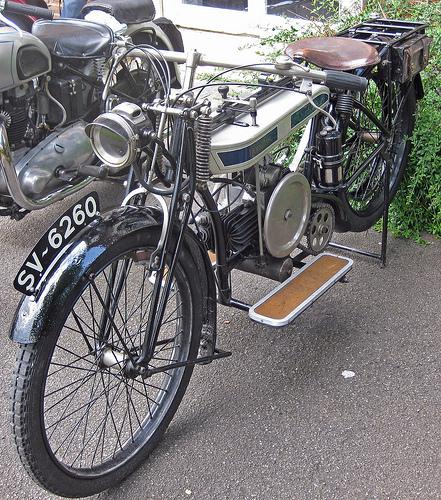Question: what type of vehicle is the main focus of this picture?
Choices:
A. A bus.
B. A car.
C. A motorized bicycle.
D. A boat.
Answer with the letter. Answer: C Question: where is the motorized bicycle resting?
Choices:
A. On the flatbed.
B. In the parking garage.
C. On the ground.
D. In the stadium.
Answer with the letter. Answer: C Question: what does it say on the license plate?
Choices:
A. Luv All.
B. Hsr-6565.
C. SV-6260.
D. Jkl-0341.
Answer with the letter. Answer: C 